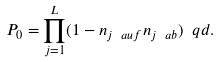<formula> <loc_0><loc_0><loc_500><loc_500>P _ { 0 } = \prod _ { j = 1 } ^ { L } ( 1 - n _ { j \ a u f } n _ { j \ a b } ) \ q d .</formula> 